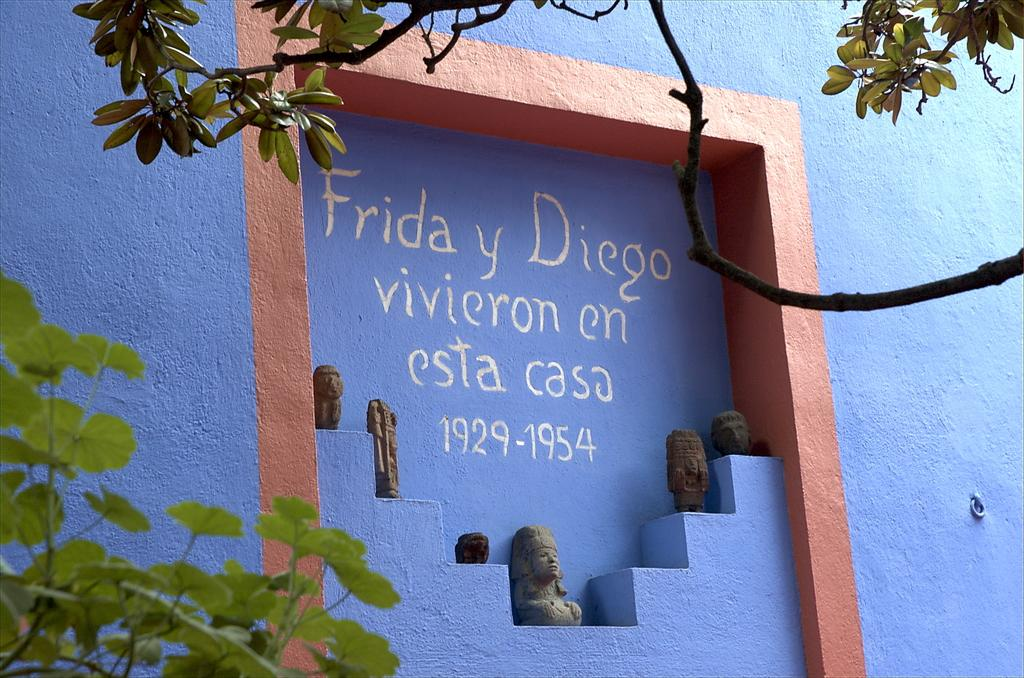What is written or depicted on the wall in the image? There is a wall with text in the image. What other objects or figures can be seen in the image? There are statues in the image. What type of natural elements are present in the image? There are trees in the image. Can you describe the wave pattern on the statues in the image? There are no waves or wave patterns present on the statues in the image. What type of pet can be seen interacting with the trees in the image? There are no pets visible in the image; it features a wall with text, statues, and trees. 